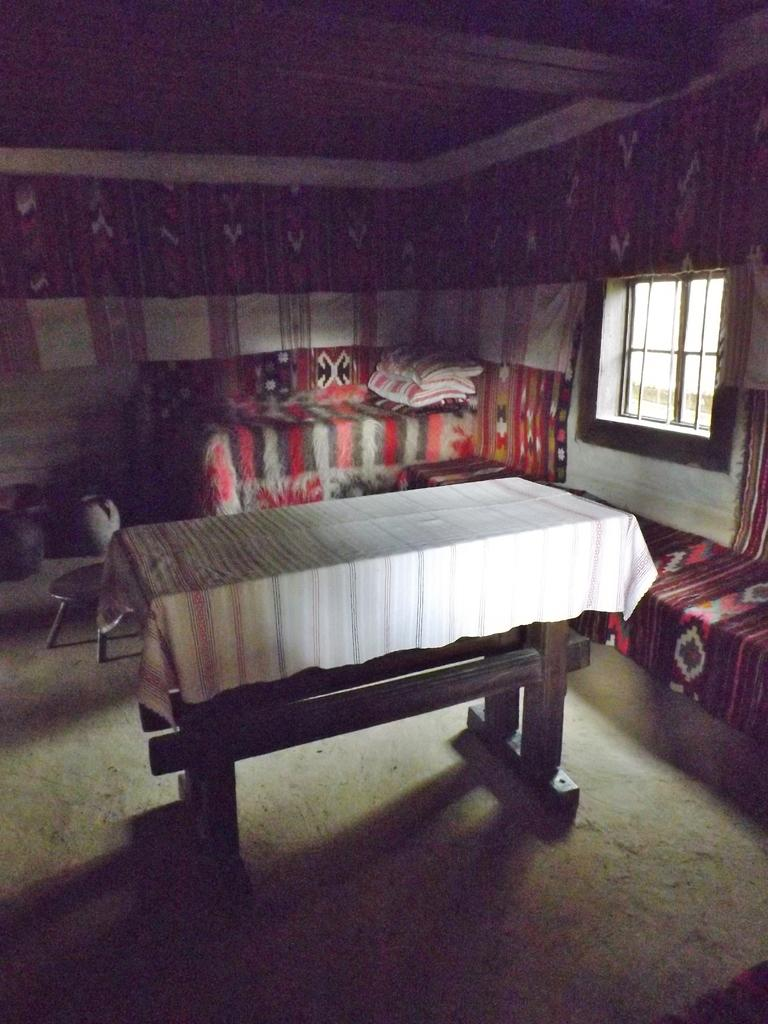What piece of furniture is present in the image? There is a table in the image. What is covering the table? The table has a cloth on it. Where is the window located in the image? The window is on the right side of the image. What can be seen in the background of the image? There are other objects visible in the backdrop of the image. What type of crack can be seen in the image? There is no crack present in the image. Is there a cracker on the table in the image? There is no cracker visible in the image. What type of cabbage is growing in the window in the image? There is no cabbage present in the image; the window is empty. 